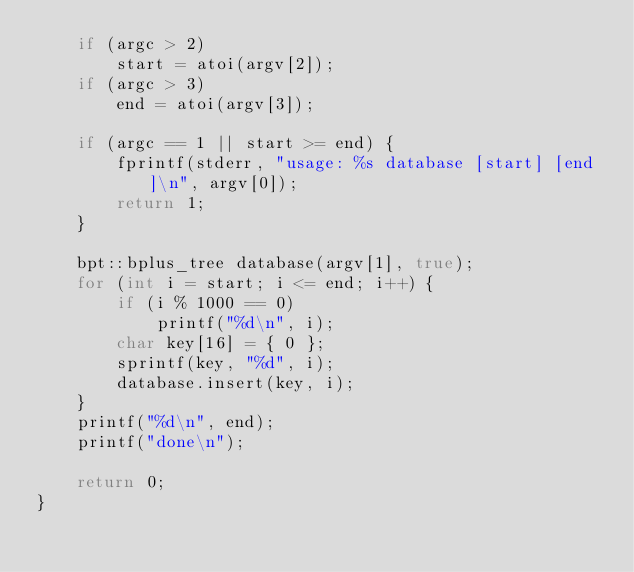Convert code to text. <code><loc_0><loc_0><loc_500><loc_500><_C++_>    if (argc > 2)
        start = atoi(argv[2]);
    if (argc > 3)
        end = atoi(argv[3]);

    if (argc == 1 || start >= end) {
        fprintf(stderr, "usage: %s database [start] [end]\n", argv[0]);
        return 1;
    }

    bpt::bplus_tree database(argv[1], true);
    for (int i = start; i <= end; i++) {
        if (i % 1000 == 0)
            printf("%d\n", i);
        char key[16] = { 0 };
        sprintf(key, "%d", i);
        database.insert(key, i);
    }
    printf("%d\n", end);
    printf("done\n");
    
    return 0;
}
</code> 